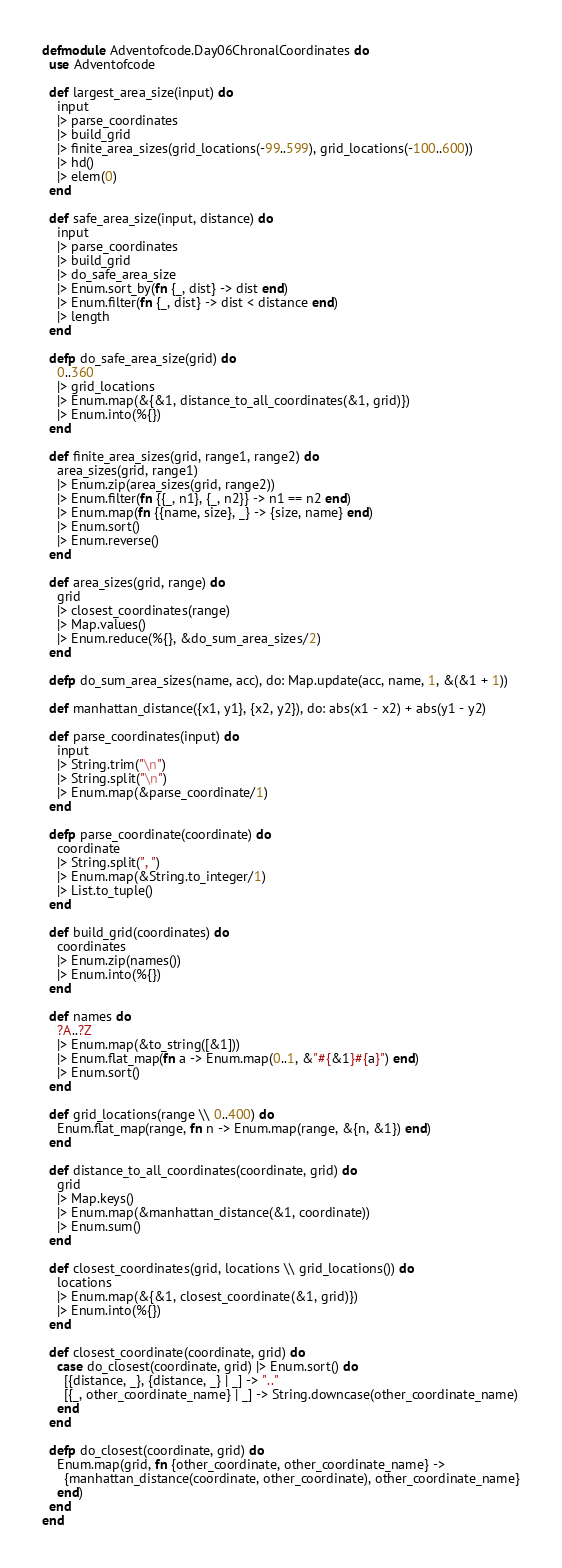<code> <loc_0><loc_0><loc_500><loc_500><_Elixir_>defmodule Adventofcode.Day06ChronalCoordinates do
  use Adventofcode

  def largest_area_size(input) do
    input
    |> parse_coordinates
    |> build_grid
    |> finite_area_sizes(grid_locations(-99..599), grid_locations(-100..600))
    |> hd()
    |> elem(0)
  end

  def safe_area_size(input, distance) do
    input
    |> parse_coordinates
    |> build_grid
    |> do_safe_area_size
    |> Enum.sort_by(fn {_, dist} -> dist end)
    |> Enum.filter(fn {_, dist} -> dist < distance end)
    |> length
  end

  defp do_safe_area_size(grid) do
    0..360
    |> grid_locations
    |> Enum.map(&{&1, distance_to_all_coordinates(&1, grid)})
    |> Enum.into(%{})
  end

  def finite_area_sizes(grid, range1, range2) do
    area_sizes(grid, range1)
    |> Enum.zip(area_sizes(grid, range2))
    |> Enum.filter(fn {{_, n1}, {_, n2}} -> n1 == n2 end)
    |> Enum.map(fn {{name, size}, _} -> {size, name} end)
    |> Enum.sort()
    |> Enum.reverse()
  end

  def area_sizes(grid, range) do
    grid
    |> closest_coordinates(range)
    |> Map.values()
    |> Enum.reduce(%{}, &do_sum_area_sizes/2)
  end

  defp do_sum_area_sizes(name, acc), do: Map.update(acc, name, 1, &(&1 + 1))

  def manhattan_distance({x1, y1}, {x2, y2}), do: abs(x1 - x2) + abs(y1 - y2)

  def parse_coordinates(input) do
    input
    |> String.trim("\n")
    |> String.split("\n")
    |> Enum.map(&parse_coordinate/1)
  end

  defp parse_coordinate(coordinate) do
    coordinate
    |> String.split(", ")
    |> Enum.map(&String.to_integer/1)
    |> List.to_tuple()
  end

  def build_grid(coordinates) do
    coordinates
    |> Enum.zip(names())
    |> Enum.into(%{})
  end

  def names do
    ?A..?Z
    |> Enum.map(&to_string([&1]))
    |> Enum.flat_map(fn a -> Enum.map(0..1, &"#{&1}#{a}") end)
    |> Enum.sort()
  end

  def grid_locations(range \\ 0..400) do
    Enum.flat_map(range, fn n -> Enum.map(range, &{n, &1}) end)
  end

  def distance_to_all_coordinates(coordinate, grid) do
    grid
    |> Map.keys()
    |> Enum.map(&manhattan_distance(&1, coordinate))
    |> Enum.sum()
  end

  def closest_coordinates(grid, locations \\ grid_locations()) do
    locations
    |> Enum.map(&{&1, closest_coordinate(&1, grid)})
    |> Enum.into(%{})
  end

  def closest_coordinate(coordinate, grid) do
    case do_closest(coordinate, grid) |> Enum.sort() do
      [{distance, _}, {distance, _} | _] -> ".."
      [{_, other_coordinate_name} | _] -> String.downcase(other_coordinate_name)
    end
  end

  defp do_closest(coordinate, grid) do
    Enum.map(grid, fn {other_coordinate, other_coordinate_name} ->
      {manhattan_distance(coordinate, other_coordinate), other_coordinate_name}
    end)
  end
end
</code> 